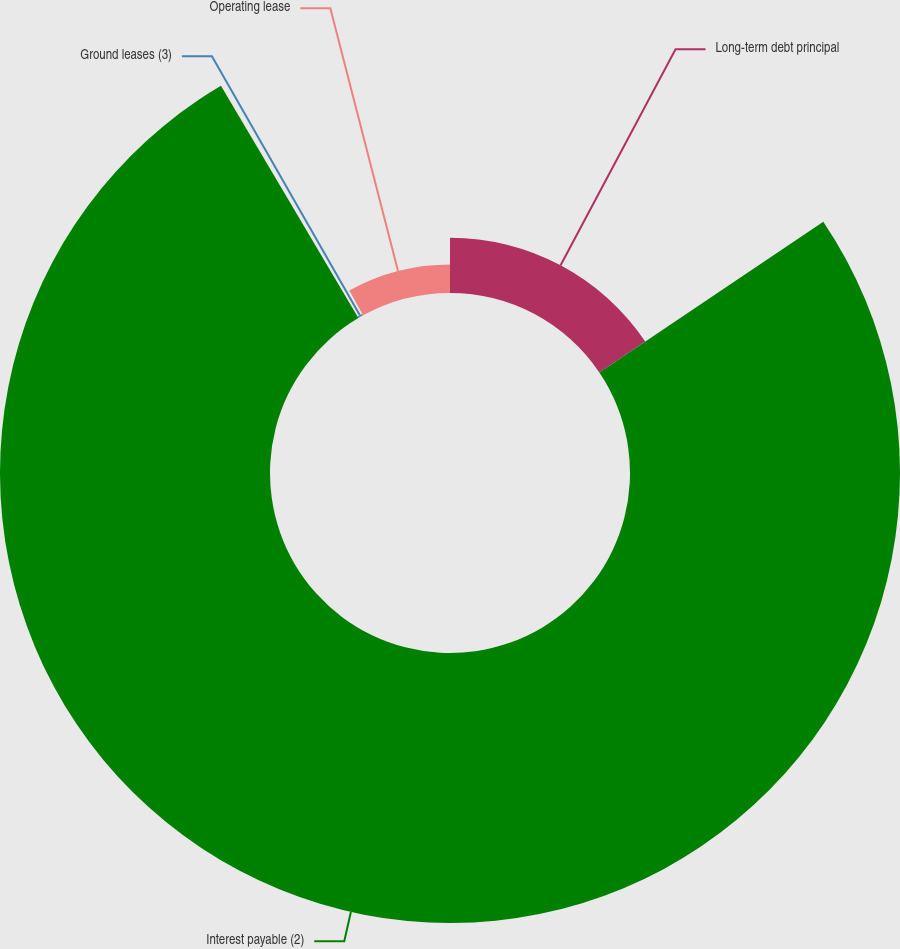Convert chart. <chart><loc_0><loc_0><loc_500><loc_500><pie_chart><fcel>Long-term debt principal<fcel>Interest payable (2)<fcel>Ground leases (3)<fcel>Operating lease<nl><fcel>15.57%<fcel>75.93%<fcel>0.48%<fcel>8.02%<nl></chart> 